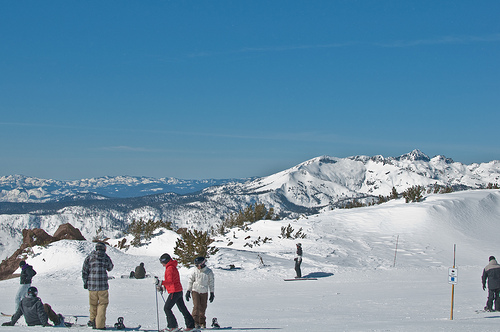<image>What type of skiing is taking place in the image? It is unanswerable what type of skiing is taking place in the image. It could be downhill, cross country, or ice skiing. What type of skiing is taking place in the image? I am not sure what type of skiing is taking place in the image. It can be either mountain skiing, downhill skiing, cross country skiing or ice skiing. 